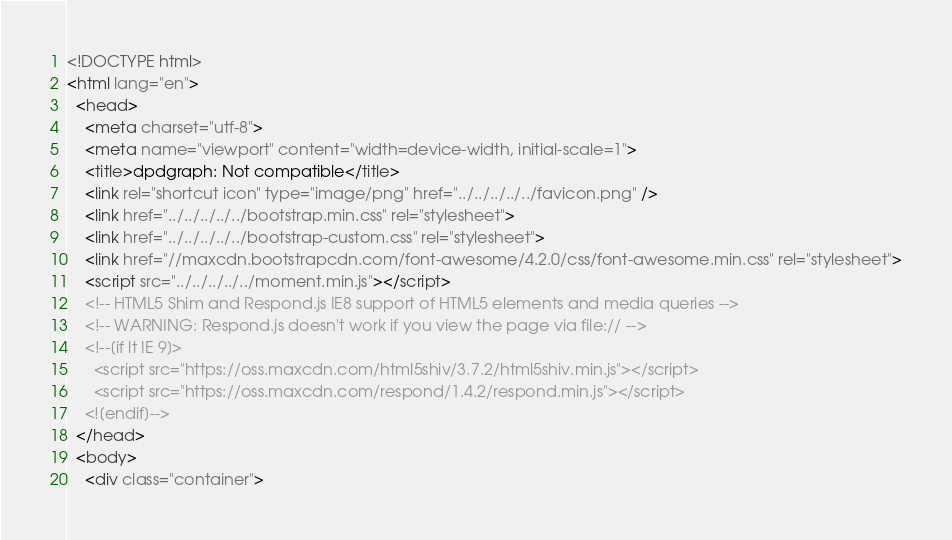<code> <loc_0><loc_0><loc_500><loc_500><_HTML_><!DOCTYPE html>
<html lang="en">
  <head>
    <meta charset="utf-8">
    <meta name="viewport" content="width=device-width, initial-scale=1">
    <title>dpdgraph: Not compatible</title>
    <link rel="shortcut icon" type="image/png" href="../../../../../favicon.png" />
    <link href="../../../../../bootstrap.min.css" rel="stylesheet">
    <link href="../../../../../bootstrap-custom.css" rel="stylesheet">
    <link href="//maxcdn.bootstrapcdn.com/font-awesome/4.2.0/css/font-awesome.min.css" rel="stylesheet">
    <script src="../../../../../moment.min.js"></script>
    <!-- HTML5 Shim and Respond.js IE8 support of HTML5 elements and media queries -->
    <!-- WARNING: Respond.js doesn't work if you view the page via file:// -->
    <!--[if lt IE 9]>
      <script src="https://oss.maxcdn.com/html5shiv/3.7.2/html5shiv.min.js"></script>
      <script src="https://oss.maxcdn.com/respond/1.4.2/respond.min.js"></script>
    <![endif]-->
  </head>
  <body>
    <div class="container"></code> 